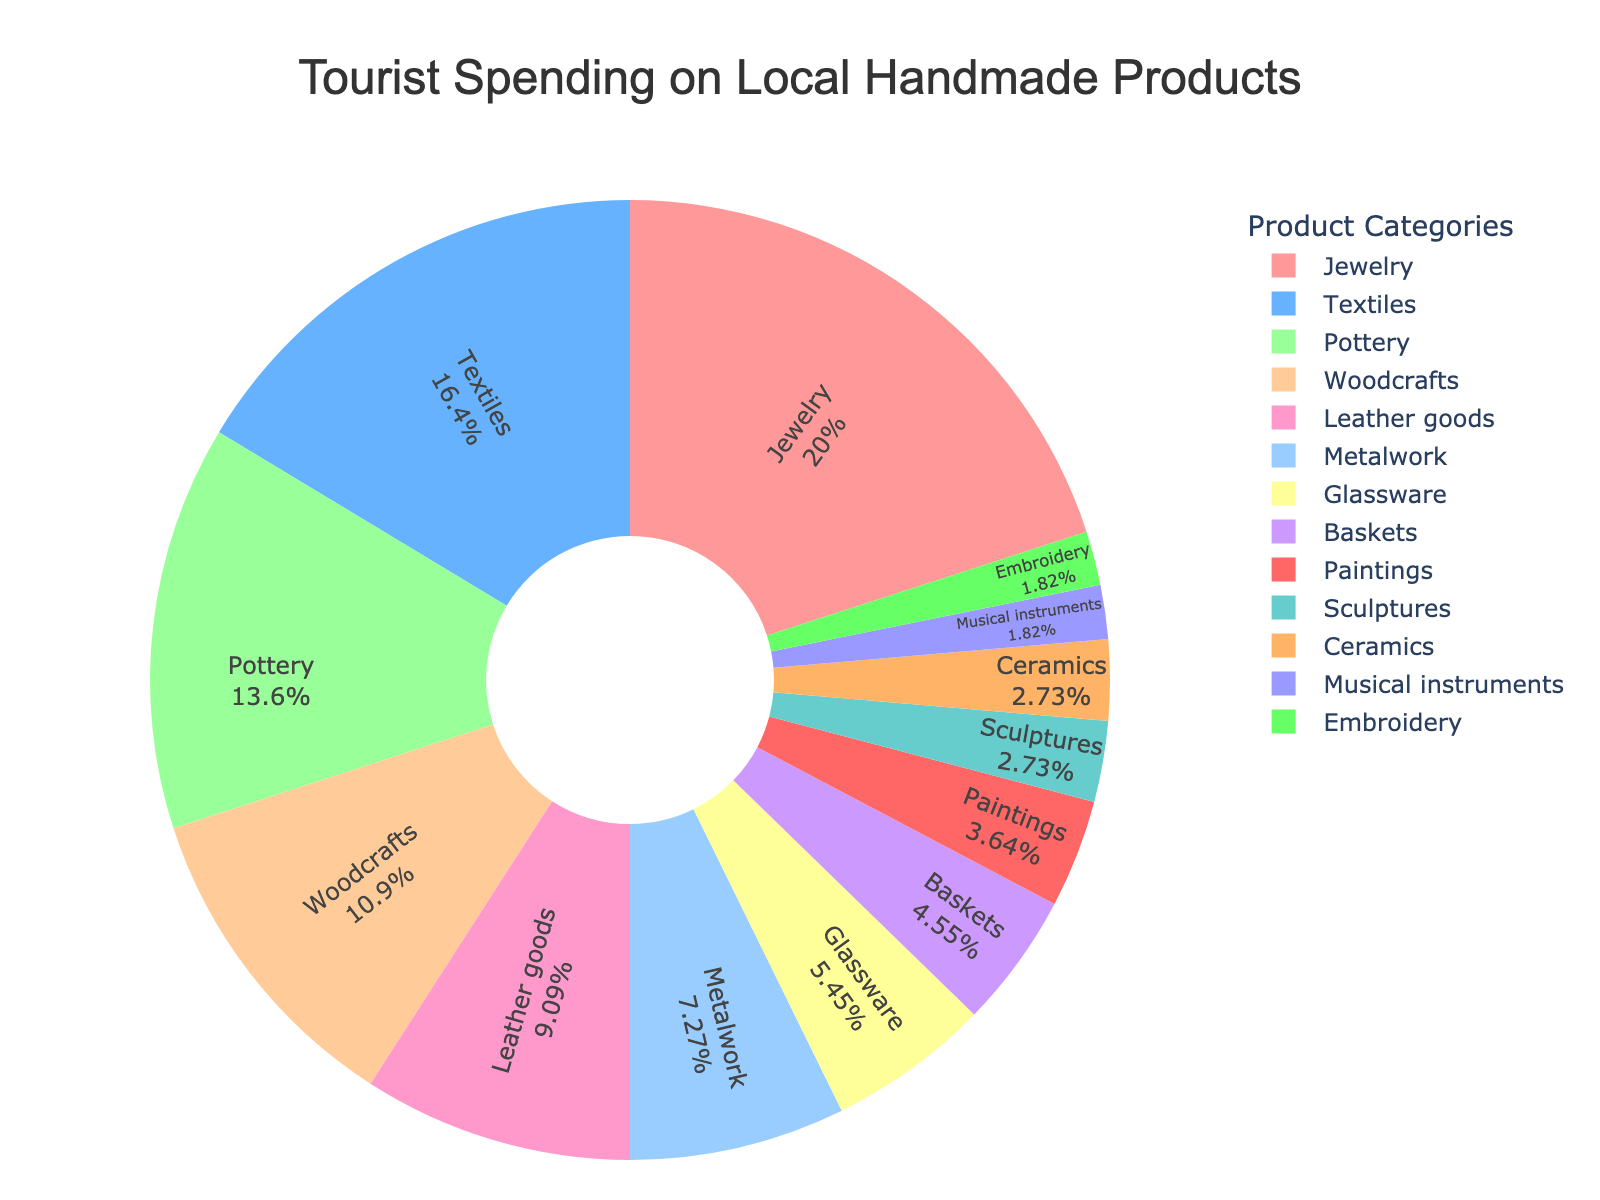What is the total percentage spent on Jewelry and Textiles? To find the total percentage spent on Jewelry and Textiles, sum their individual percentages: Jewelry (22%) + Textiles (18%) = 40%.
Answer: 40% Which category has the smallest percentage of tourist spending? Look for the category with the smallest percentage value in the pie chart, which is Musical Instruments at 2%.
Answer: Musical Instruments How much more do tourists spend on Pottery compared to Glassware? Subtract the percentage spent on Glassware from the percentage spent on Pottery: Pottery (15%) - Glassware (6%) = 9%.
Answer: 9% What is the total percentage spent on products that have more than 10% of the spending? Identify the categories with more than 10% spending: Jewelry (22%), Textiles (18%), Pottery (15%), Woodcrafts (12%). Sum these percentages: 22% + 18% + 15% + 12% = 67%.
Answer: 67% Which two categories combined make up the same percentage as Leather Goods? Find two categories whose combined spending equals the spending on Leather Goods (10%). Here, Metalwork (8%) and Musical Instruments (2%) combined equal 10%.
Answer: Metalwork and Musical Instruments Is the percentage spent on Baskets greater or less than that spent on Metalwork? Compare the percentages: Baskets (5%) and Metalwork (8%). Since 5% is less than 8%, Baskets has a smaller percentage.
Answer: Less How many categories have a spending percentage of less than 5%? Count the categories with percentages less than 5%: Paintings (4%), Sculptures (3%), Ceramics (3%), Musical Instruments (2%), and Embroidery (2%). There are 5 such categories.
Answer: 5 What is the average percentage of spending across all categories? To calculate the average, sum all the percentages and divide by the number of categories: (22% + 18% + 15% + 12% + 10% + 8% + 6% + 5% + 4% + 3% + 3% + 2% + 2%) / 13 = 110% / 13 ≈8.46%.
Answer: 8.46% Which category is depicted in red on the pie chart? Based on the color order mentioned, the Jewelry category is depicted in red.
Answer: Jewelry What is the difference in tourist spending between the two largest categories? The two largest categories are Jewelry (22%) and Textiles (18%). The difference is 22% - 18% = 4%.
Answer: 4% 